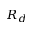<formula> <loc_0><loc_0><loc_500><loc_500>R _ { d }</formula> 